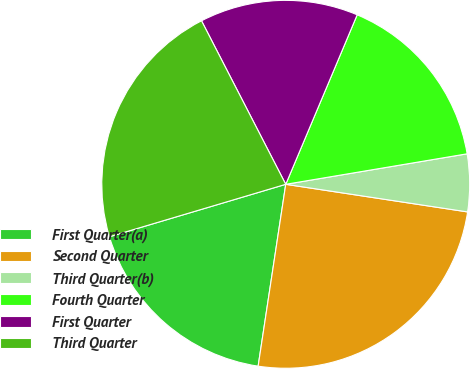Convert chart. <chart><loc_0><loc_0><loc_500><loc_500><pie_chart><fcel>First Quarter(a)<fcel>Second Quarter<fcel>Third Quarter(b)<fcel>Fourth Quarter<fcel>First Quarter<fcel>Third Quarter<nl><fcel>18.0%<fcel>25.0%<fcel>5.05%<fcel>16.0%<fcel>13.92%<fcel>22.03%<nl></chart> 